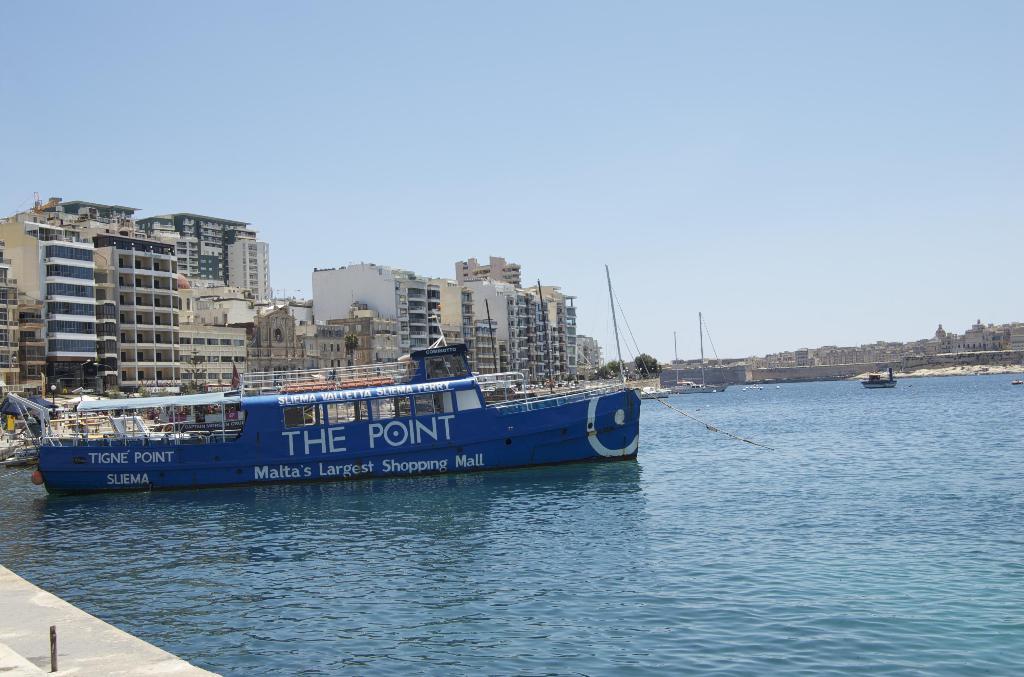What type of point is mentioned on the boats rear?
Provide a short and direct response. Tigne. What is malta's largest shopping mall?
Your response must be concise. The point. 